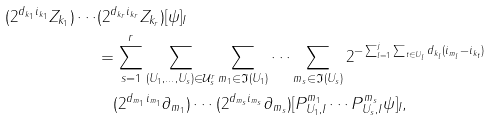<formula> <loc_0><loc_0><loc_500><loc_500>( 2 ^ { d _ { k _ { 1 } } i _ { k _ { 1 } } } Z _ { k _ { 1 } } ) \cdots & ( 2 ^ { d _ { k _ { r } } i _ { k _ { r } } } Z _ { k _ { r } } ) [ \psi ] _ { I } \\ & = \sum _ { s = 1 } ^ { r } \sum _ { ( U _ { 1 } , \dots , U _ { s } ) \in \mathcal { U } ^ { r } _ { s } } \sum _ { m _ { 1 } \in \mathfrak I ( U _ { 1 } ) } \cdots \sum _ { m _ { s } \in \mathfrak I ( U _ { s } ) } 2 ^ { - \sum _ { l = 1 } ^ { j } \sum _ { t \in U _ { l } } d _ { k _ { l } } ( i _ { m _ { l } } - i _ { k _ { t } } ) } \\ & \quad ( 2 ^ { d _ { m _ { 1 } } i _ { m _ { 1 } } } \partial _ { m _ { 1 } } ) \cdots ( 2 ^ { d _ { m _ { s } } i _ { m _ { s } } } \partial _ { m _ { s } } ) [ P ^ { m _ { 1 } } _ { U _ { 1 } , I } \cdots P ^ { m _ { s } } _ { U _ { s } , I } \psi ] _ { I } ,</formula> 